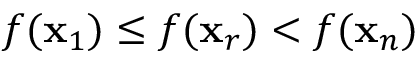<formula> <loc_0><loc_0><loc_500><loc_500>f ( x _ { 1 } ) \leq f ( x _ { r } ) < f ( x _ { n } )</formula> 